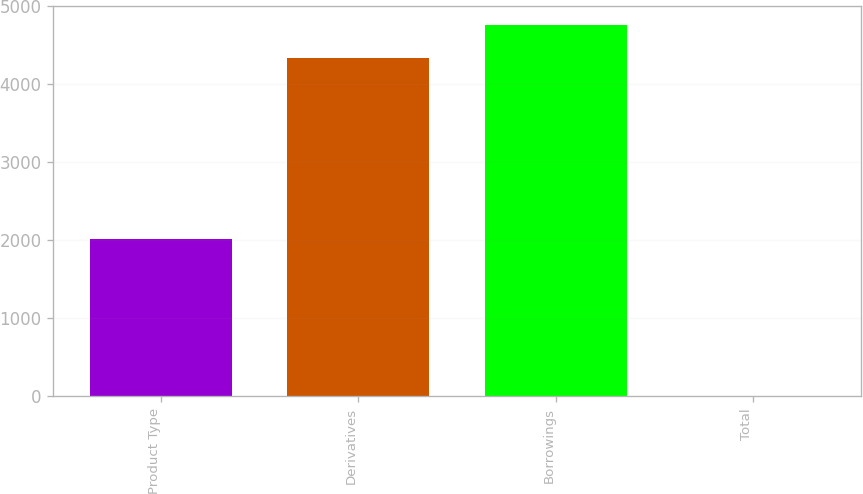<chart> <loc_0><loc_0><loc_500><loc_500><bar_chart><fcel>Product Type<fcel>Derivatives<fcel>Borrowings<fcel>Total<nl><fcel>2013<fcel>4332<fcel>4765.2<fcel>3<nl></chart> 